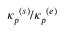<formula> <loc_0><loc_0><loc_500><loc_500>{ \kappa _ { p } } ^ { ( s ) } / { \kappa _ { p } } ^ { ( e ) }</formula> 